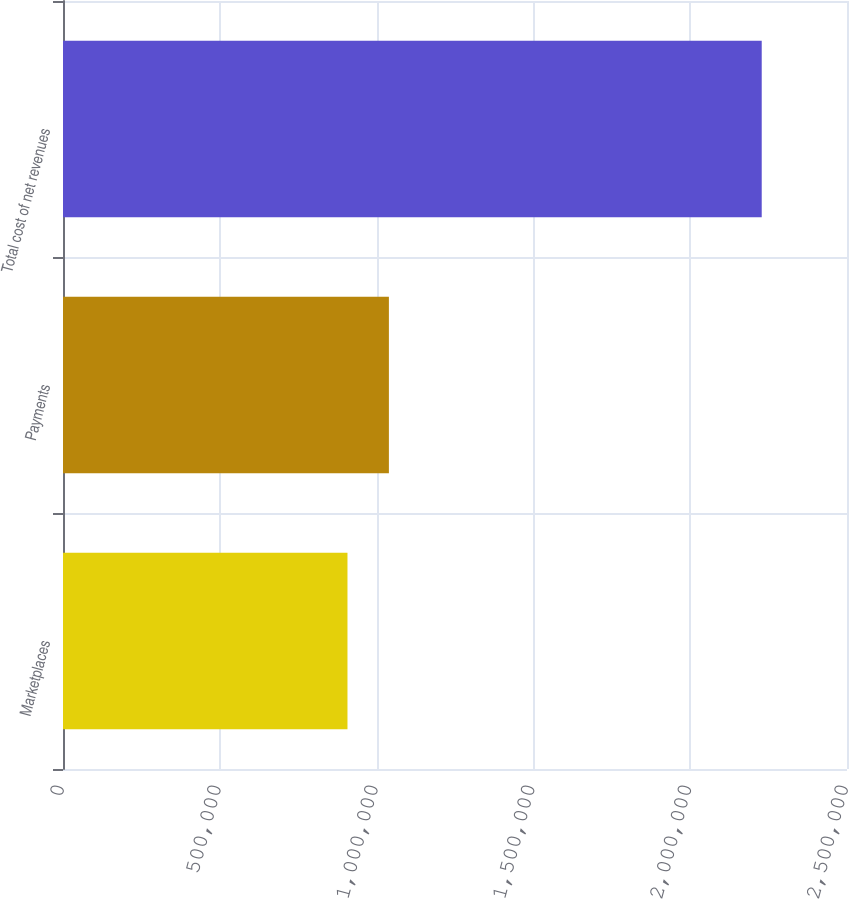<chart> <loc_0><loc_0><loc_500><loc_500><bar_chart><fcel>Marketplaces<fcel>Payments<fcel>Total cost of net revenues<nl><fcel>907121<fcel>1.03922e+06<fcel>2.22807e+06<nl></chart> 